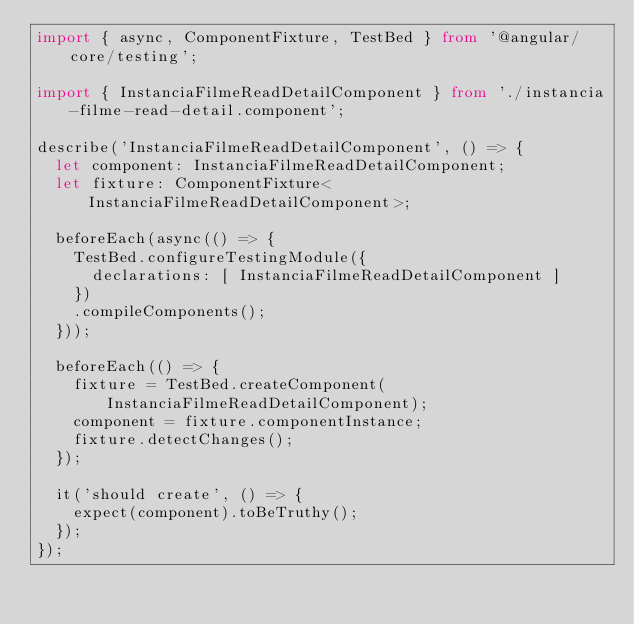Convert code to text. <code><loc_0><loc_0><loc_500><loc_500><_TypeScript_>import { async, ComponentFixture, TestBed } from '@angular/core/testing';

import { InstanciaFilmeReadDetailComponent } from './instancia-filme-read-detail.component';

describe('InstanciaFilmeReadDetailComponent', () => {
  let component: InstanciaFilmeReadDetailComponent;
  let fixture: ComponentFixture<InstanciaFilmeReadDetailComponent>;

  beforeEach(async(() => {
    TestBed.configureTestingModule({
      declarations: [ InstanciaFilmeReadDetailComponent ]
    })
    .compileComponents();
  }));

  beforeEach(() => {
    fixture = TestBed.createComponent(InstanciaFilmeReadDetailComponent);
    component = fixture.componentInstance;
    fixture.detectChanges();
  });

  it('should create', () => {
    expect(component).toBeTruthy();
  });
});
</code> 